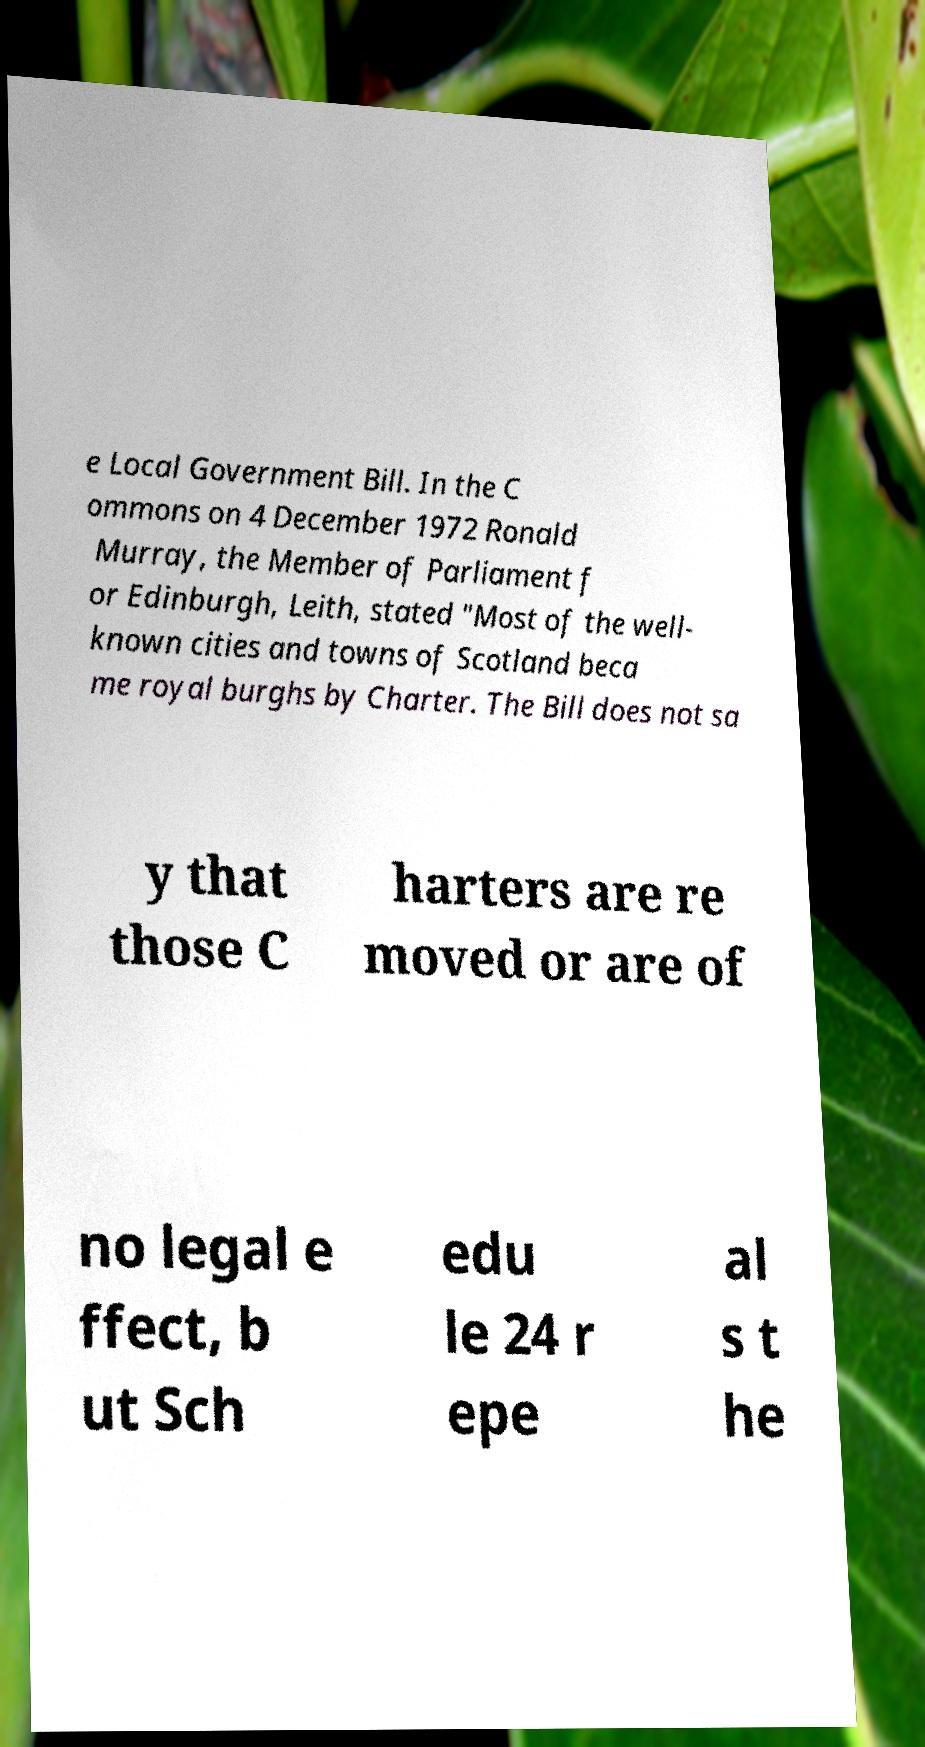I need the written content from this picture converted into text. Can you do that? e Local Government Bill. In the C ommons on 4 December 1972 Ronald Murray, the Member of Parliament f or Edinburgh, Leith, stated "Most of the well- known cities and towns of Scotland beca me royal burghs by Charter. The Bill does not sa y that those C harters are re moved or are of no legal e ffect, b ut Sch edu le 24 r epe al s t he 